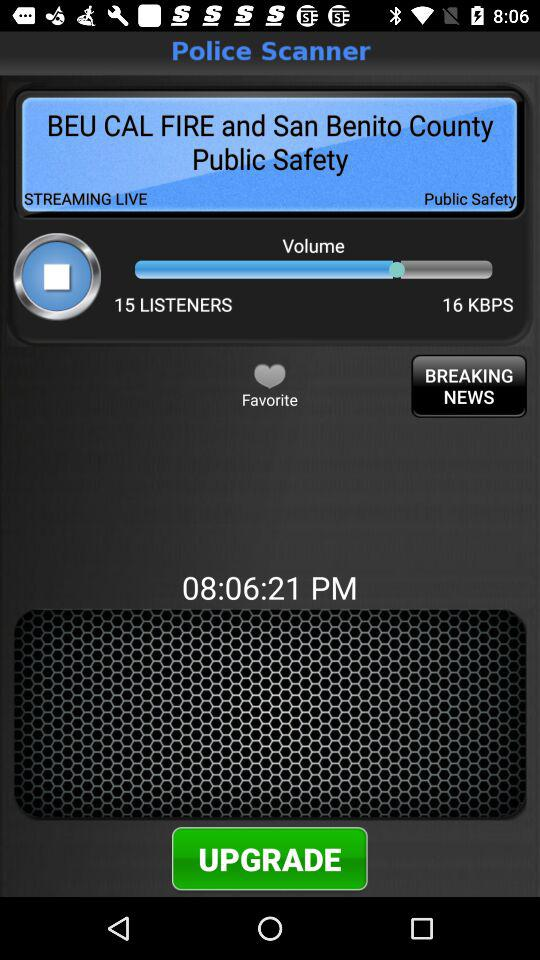What is the total number of people who are listening? There are 15 people who are listening. 